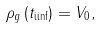Convert formula to latex. <formula><loc_0><loc_0><loc_500><loc_500>\rho _ { g } \left ( t _ { \text {iinf} } \right ) = V _ { 0 } ,</formula> 